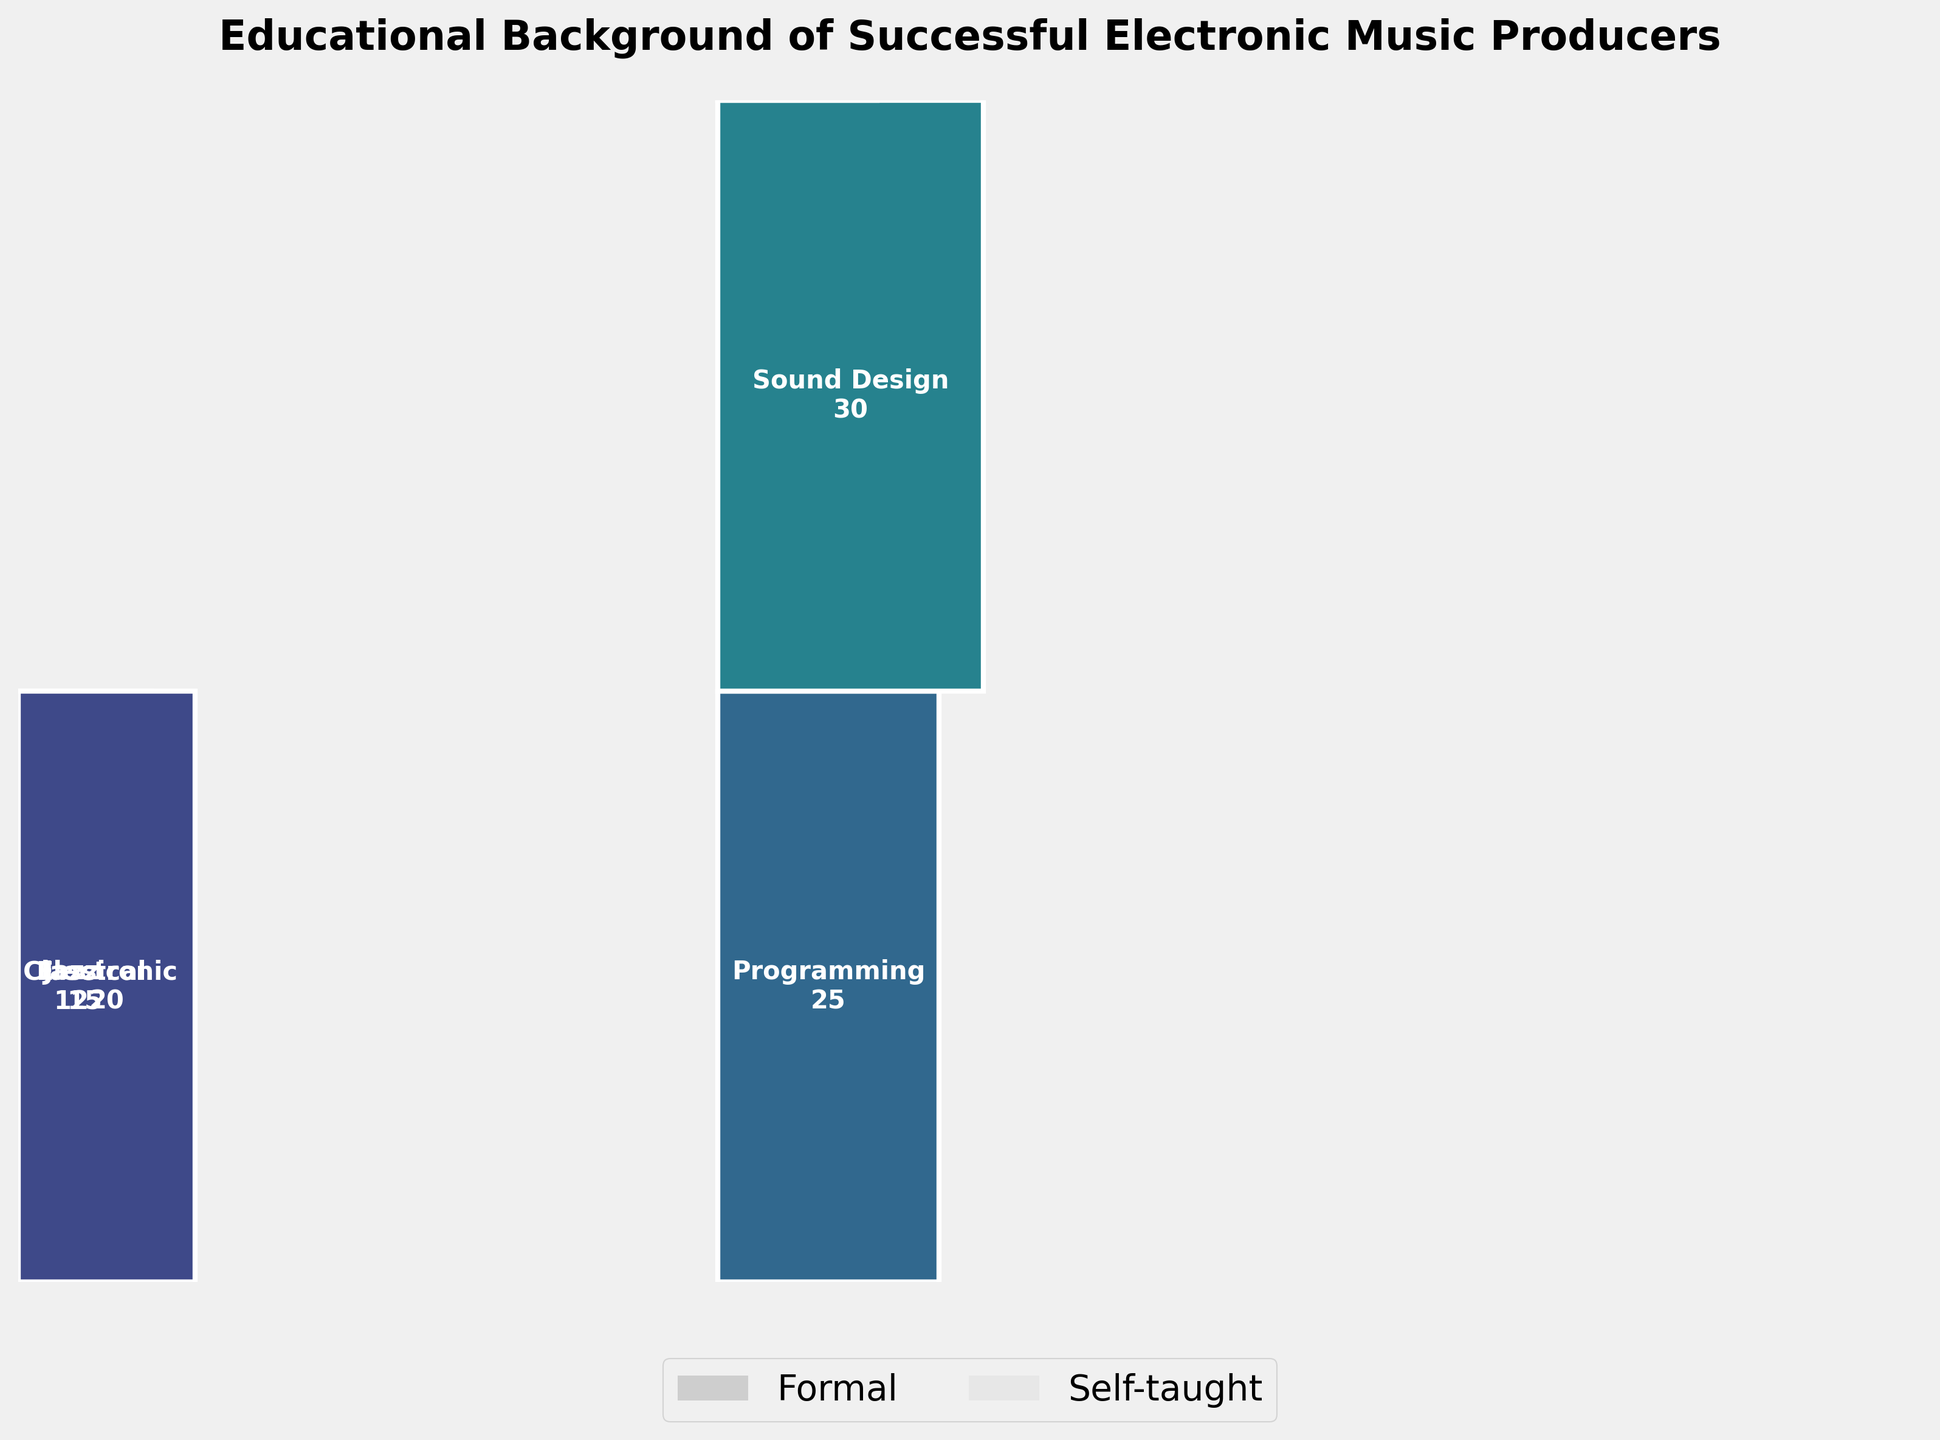How many categories of background are depicted for formal music education? The figure shows rectangles labeled for different categories. Count the distinct backgrounds listed under formal education: Classical, Jazz, Electronic, Audio Engineering, Composition.
Answer: 5 Which educational background has the highest count? Observe the labels and counts within the rectangles. The highest count among the backgrounds is Sound Design with 30.
Answer: Sound Design What is the total number of producers with self-taught educational backgrounds? Sum the counts of all self-taught categories: Programming (25) + Sound Design (30) + Music Theory (18) + Digital Production (35) + Synth Programming (28). The total is 25 + 30 + 18 + 35 + 28 = 136.
Answer: 136 Is the count of producers with a background in Audio Engineering higher or lower than those with a background in Electronic music? Compare the counts listed for Audio Engineering (22) and Electronic (20).
Answer: Higher What percentage of the total does the category with the highest count represent? The highest count is Sound Design (30). The total count from the data is 180. Calculate the percentage: (30 / 180) * 100 = 16.67%.
Answer: 16.67% Which category has the smallest count and how many producers does it include? Find the category with the smallest count from the figure, which is Composition with 10 producers.
Answer: Composition, 10 Compare the total number of formally educated producers to self-taught producers. Which group is larger? Sum the counts: Formal (15 + 12 + 20 + 22 + 10 = 79), Self-taught (136). Compare the totals, self-taught (136) is larger than formal (79).
Answer: Self-taught In the self-taught category, which background has the closest count to Music Theory (18)? Compare the counts within self-taught backgrounds. Programming (25), Digital Production (35), Sound Design (30), Synth Programming (28). The closest to Music Theory is Programming (25).
Answer: Programming If you combine the counts of Jazz and Classical backgrounds under formal education, what percentage do they represent of the total formal education count? Combine counts of Jazz (12) and Classical (15): 12 + 15 = 27. The total for formal education is 79. Calculate percentage: (27 / 79) * 100 ≈ 34.18%.
Answer: 34.18% 